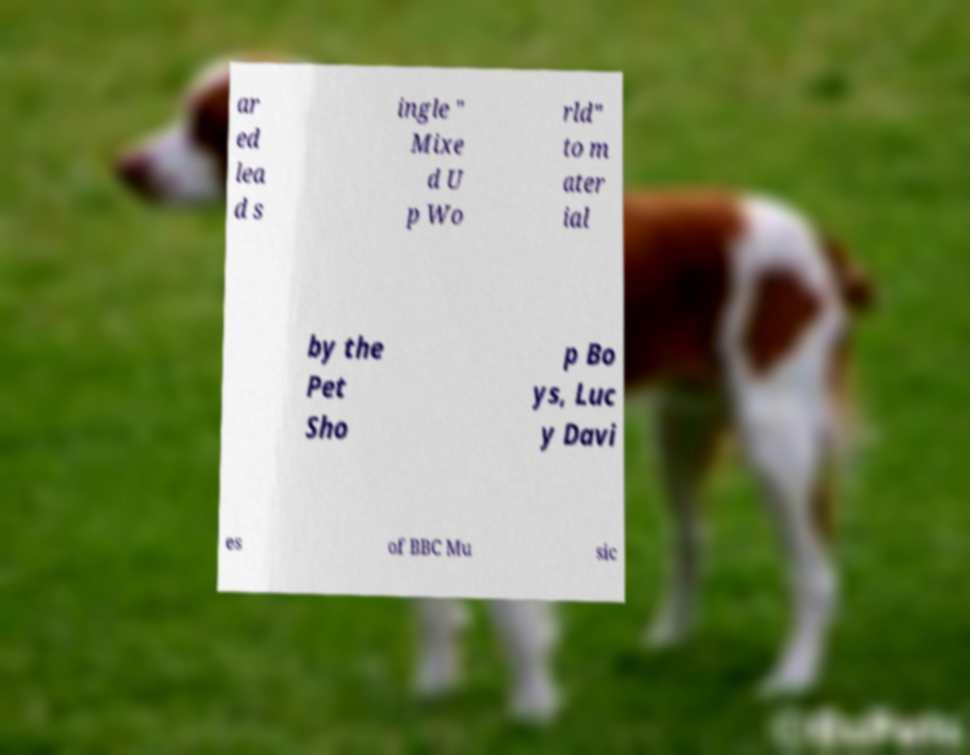Can you accurately transcribe the text from the provided image for me? ar ed lea d s ingle " Mixe d U p Wo rld" to m ater ial by the Pet Sho p Bo ys, Luc y Davi es of BBC Mu sic 